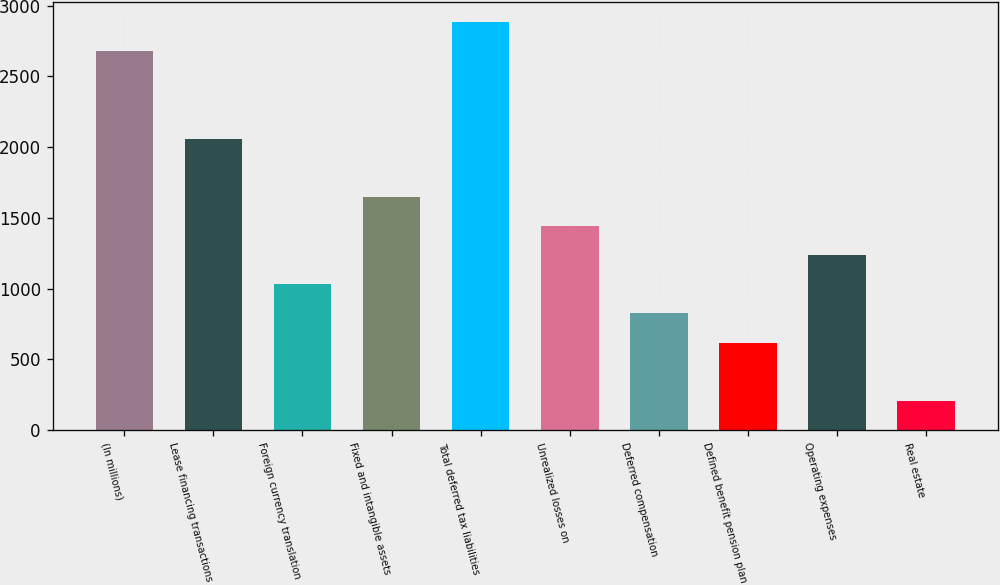<chart> <loc_0><loc_0><loc_500><loc_500><bar_chart><fcel>(In millions)<fcel>Lease financing transactions<fcel>Foreign currency translation<fcel>Fixed and intangible assets<fcel>Total deferred tax liabilities<fcel>Unrealized losses on<fcel>Deferred compensation<fcel>Defined benefit pension plan<fcel>Operating expenses<fcel>Real estate<nl><fcel>2677.4<fcel>2060<fcel>1031<fcel>1648.4<fcel>2883.2<fcel>1442.6<fcel>825.2<fcel>619.4<fcel>1236.8<fcel>207.8<nl></chart> 